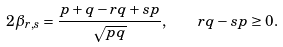<formula> <loc_0><loc_0><loc_500><loc_500>2 \beta _ { r , s } = \frac { p + q - r q + s p } { \sqrt { p q } } , \quad r q - s p \geq 0 .</formula> 